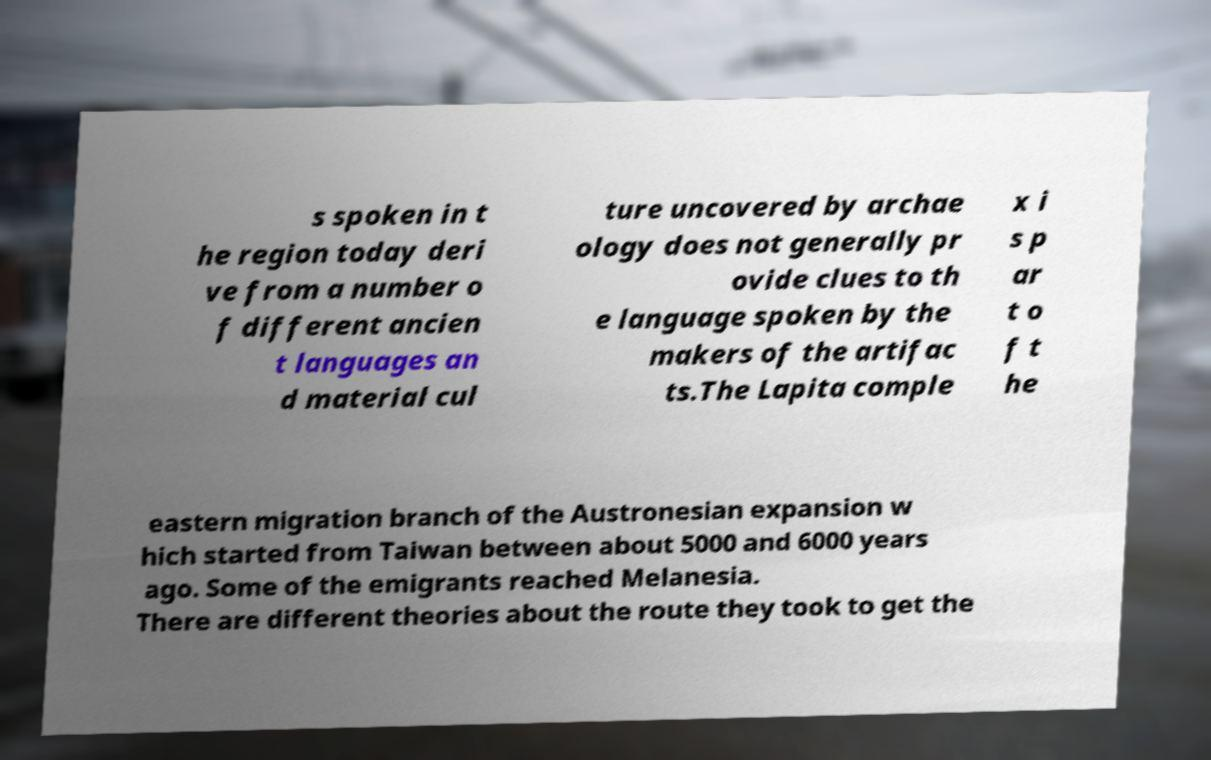Please identify and transcribe the text found in this image. s spoken in t he region today deri ve from a number o f different ancien t languages an d material cul ture uncovered by archae ology does not generally pr ovide clues to th e language spoken by the makers of the artifac ts.The Lapita comple x i s p ar t o f t he eastern migration branch of the Austronesian expansion w hich started from Taiwan between about 5000 and 6000 years ago. Some of the emigrants reached Melanesia. There are different theories about the route they took to get the 